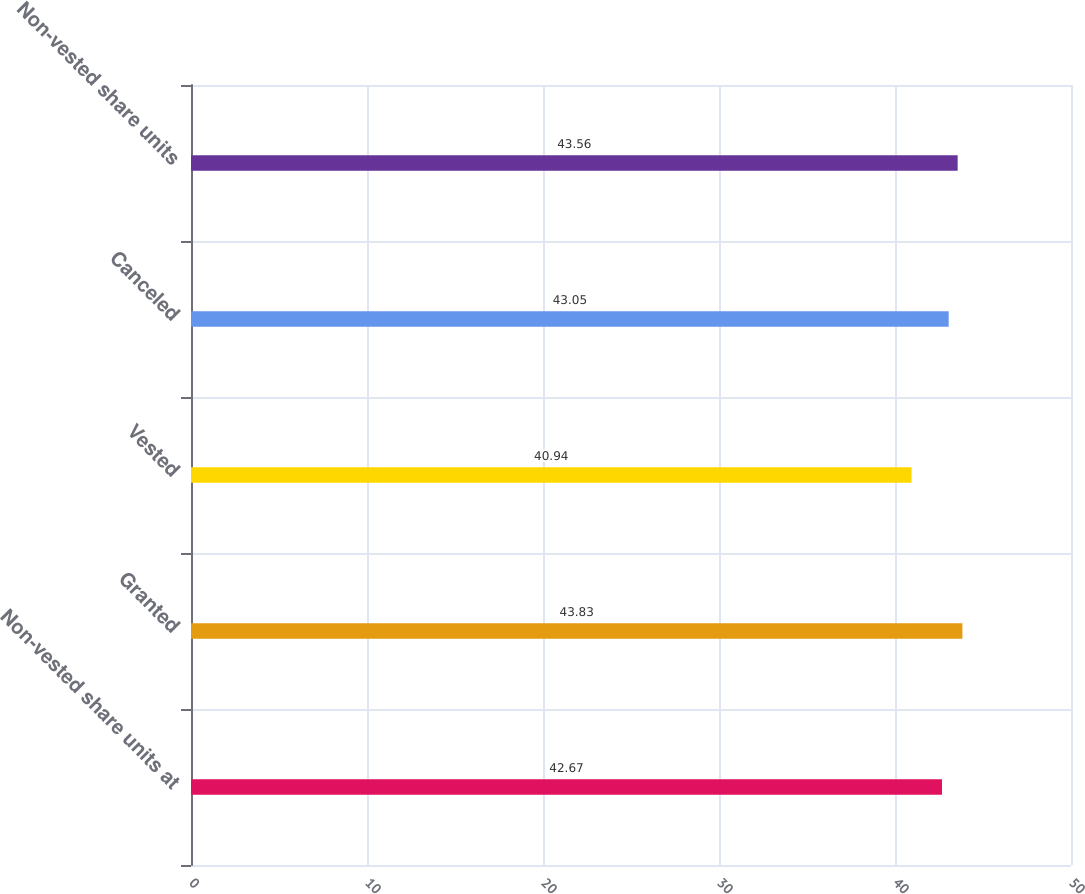Convert chart. <chart><loc_0><loc_0><loc_500><loc_500><bar_chart><fcel>Non-vested share units at<fcel>Granted<fcel>Vested<fcel>Canceled<fcel>Non-vested share units<nl><fcel>42.67<fcel>43.83<fcel>40.94<fcel>43.05<fcel>43.56<nl></chart> 